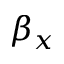Convert formula to latex. <formula><loc_0><loc_0><loc_500><loc_500>\beta _ { x }</formula> 